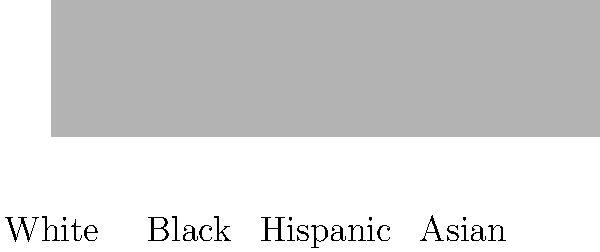Based on the voter turnout patterns shown in the bar graph, which demographic group would be most affected by implementing stricter voter ID laws and reducing early voting options? To answer this question, we need to analyze the voter turnout patterns for each demographic group:

1. White voters: Approximately 75% turnout
2. Black voters: Approximately 60% turnout
3. Hispanic voters: Approximately 45% turnout
4. Asian voters: Approximately 30% turnout

Implementing stricter voter ID laws and reducing early voting options typically have a disproportionate impact on minority groups and those with lower voter turnout rates. This is because:

1. Minority groups are less likely to have government-issued IDs.
2. Lower-income individuals, who are overrepresented in minority groups, may have difficulty taking time off work to vote on a single day.
3. Groups with lower turnout rates are more susceptible to additional barriers to voting.

Given this information, we can conclude that the Black demographic group would be most affected by these changes. They have the second-highest turnout rate (60%) among minority groups, which means:

1. They represent a significant voting bloc.
2. Any reduction in their turnout could have a substantial impact on election results.
3. They are more likely to be affected by stricter voting laws compared to the White demographic, which has the highest turnout and is generally less impacted by such measures.

While Hispanic and Asian voters have lower turnout rates, targeting the Black demographic would likely have a more significant impact on election outcomes due to their higher participation rate.
Answer: Black voters 